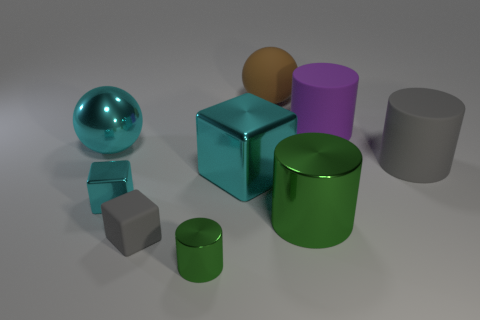Subtract all large green metal cylinders. How many cylinders are left? 3 Subtract all purple cylinders. How many cylinders are left? 3 Subtract all spheres. How many objects are left? 7 Subtract 1 spheres. How many spheres are left? 1 Subtract all purple cylinders. Subtract all brown spheres. How many cylinders are left? 3 Subtract all blue cylinders. How many brown spheres are left? 1 Subtract all green rubber cylinders. Subtract all cyan metallic spheres. How many objects are left? 8 Add 1 tiny matte blocks. How many tiny matte blocks are left? 2 Add 9 large purple cylinders. How many large purple cylinders exist? 10 Subtract 1 cyan cubes. How many objects are left? 8 